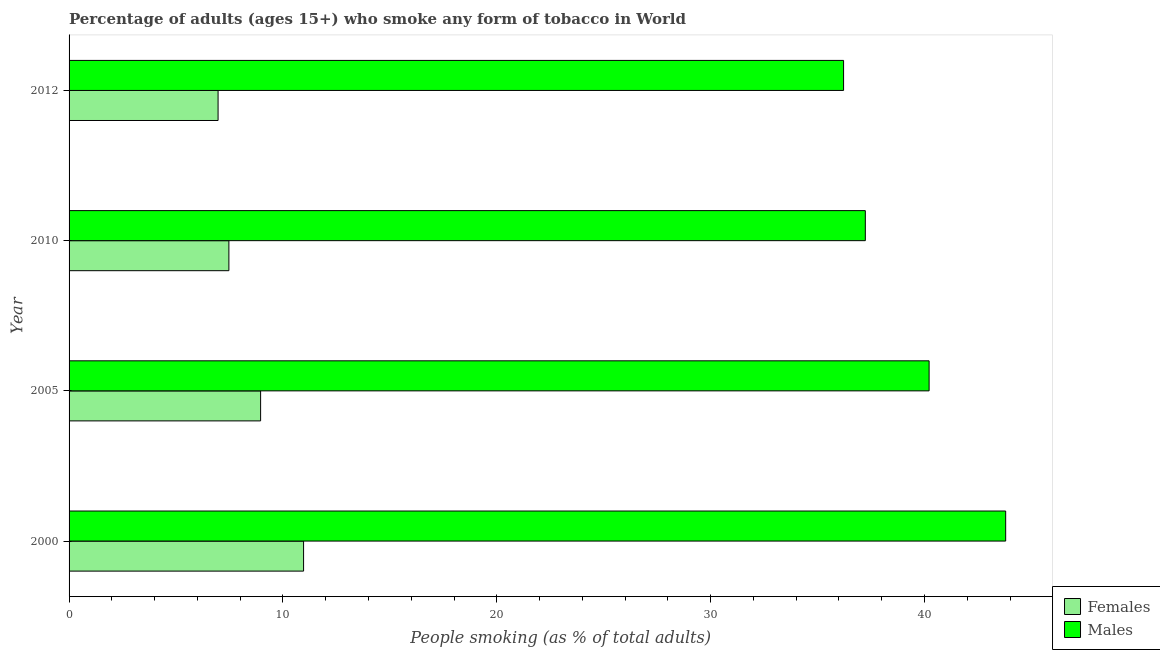How many groups of bars are there?
Ensure brevity in your answer.  4. Are the number of bars per tick equal to the number of legend labels?
Offer a terse response. Yes. In how many cases, is the number of bars for a given year not equal to the number of legend labels?
Give a very brief answer. 0. What is the percentage of males who smoke in 2012?
Your response must be concise. 36.22. Across all years, what is the maximum percentage of females who smoke?
Offer a terse response. 10.97. Across all years, what is the minimum percentage of males who smoke?
Offer a very short reply. 36.22. What is the total percentage of males who smoke in the graph?
Offer a terse response. 157.46. What is the difference between the percentage of females who smoke in 2000 and that in 2005?
Ensure brevity in your answer.  2.01. What is the difference between the percentage of males who smoke in 2000 and the percentage of females who smoke in 2005?
Keep it short and to the point. 34.84. What is the average percentage of males who smoke per year?
Your response must be concise. 39.37. In the year 2000, what is the difference between the percentage of males who smoke and percentage of females who smoke?
Keep it short and to the point. 32.83. What is the ratio of the percentage of males who smoke in 2000 to that in 2012?
Offer a very short reply. 1.21. Is the percentage of males who smoke in 2000 less than that in 2012?
Keep it short and to the point. No. What is the difference between the highest and the second highest percentage of females who smoke?
Give a very brief answer. 2.01. What is the difference between the highest and the lowest percentage of females who smoke?
Make the answer very short. 4. In how many years, is the percentage of males who smoke greater than the average percentage of males who smoke taken over all years?
Keep it short and to the point. 2. What does the 2nd bar from the top in 2010 represents?
Provide a succinct answer. Females. What does the 1st bar from the bottom in 2000 represents?
Provide a short and direct response. Females. What is the difference between two consecutive major ticks on the X-axis?
Keep it short and to the point. 10. Are the values on the major ticks of X-axis written in scientific E-notation?
Offer a very short reply. No. Does the graph contain any zero values?
Make the answer very short. No. Does the graph contain grids?
Offer a terse response. No. What is the title of the graph?
Make the answer very short. Percentage of adults (ages 15+) who smoke any form of tobacco in World. Does "Diarrhea" appear as one of the legend labels in the graph?
Keep it short and to the point. No. What is the label or title of the X-axis?
Provide a succinct answer. People smoking (as % of total adults). What is the People smoking (as % of total adults) of Females in 2000?
Ensure brevity in your answer.  10.97. What is the People smoking (as % of total adults) of Males in 2000?
Your answer should be very brief. 43.8. What is the People smoking (as % of total adults) in Females in 2005?
Offer a very short reply. 8.96. What is the People smoking (as % of total adults) of Males in 2005?
Your answer should be compact. 40.22. What is the People smoking (as % of total adults) in Females in 2010?
Keep it short and to the point. 7.47. What is the People smoking (as % of total adults) in Males in 2010?
Ensure brevity in your answer.  37.23. What is the People smoking (as % of total adults) of Females in 2012?
Your response must be concise. 6.97. What is the People smoking (as % of total adults) of Males in 2012?
Ensure brevity in your answer.  36.22. Across all years, what is the maximum People smoking (as % of total adults) of Females?
Offer a very short reply. 10.97. Across all years, what is the maximum People smoking (as % of total adults) in Males?
Ensure brevity in your answer.  43.8. Across all years, what is the minimum People smoking (as % of total adults) of Females?
Provide a succinct answer. 6.97. Across all years, what is the minimum People smoking (as % of total adults) in Males?
Your answer should be compact. 36.22. What is the total People smoking (as % of total adults) of Females in the graph?
Your answer should be very brief. 34.36. What is the total People smoking (as % of total adults) in Males in the graph?
Make the answer very short. 157.46. What is the difference between the People smoking (as % of total adults) of Females in 2000 and that in 2005?
Give a very brief answer. 2.01. What is the difference between the People smoking (as % of total adults) in Males in 2000 and that in 2005?
Your answer should be very brief. 3.58. What is the difference between the People smoking (as % of total adults) in Females in 2000 and that in 2010?
Provide a short and direct response. 3.49. What is the difference between the People smoking (as % of total adults) in Males in 2000 and that in 2010?
Your answer should be compact. 6.56. What is the difference between the People smoking (as % of total adults) in Females in 2000 and that in 2012?
Ensure brevity in your answer.  4. What is the difference between the People smoking (as % of total adults) of Males in 2000 and that in 2012?
Provide a succinct answer. 7.58. What is the difference between the People smoking (as % of total adults) of Females in 2005 and that in 2010?
Keep it short and to the point. 1.48. What is the difference between the People smoking (as % of total adults) of Males in 2005 and that in 2010?
Your answer should be very brief. 2.98. What is the difference between the People smoking (as % of total adults) of Females in 2005 and that in 2012?
Provide a short and direct response. 1.99. What is the difference between the People smoking (as % of total adults) in Males in 2005 and that in 2012?
Give a very brief answer. 4. What is the difference between the People smoking (as % of total adults) in Females in 2010 and that in 2012?
Ensure brevity in your answer.  0.51. What is the difference between the People smoking (as % of total adults) in Males in 2010 and that in 2012?
Provide a succinct answer. 1.02. What is the difference between the People smoking (as % of total adults) in Females in 2000 and the People smoking (as % of total adults) in Males in 2005?
Your answer should be very brief. -29.25. What is the difference between the People smoking (as % of total adults) in Females in 2000 and the People smoking (as % of total adults) in Males in 2010?
Offer a very short reply. -26.27. What is the difference between the People smoking (as % of total adults) of Females in 2000 and the People smoking (as % of total adults) of Males in 2012?
Offer a terse response. -25.25. What is the difference between the People smoking (as % of total adults) in Females in 2005 and the People smoking (as % of total adults) in Males in 2010?
Offer a very short reply. -28.28. What is the difference between the People smoking (as % of total adults) of Females in 2005 and the People smoking (as % of total adults) of Males in 2012?
Offer a terse response. -27.26. What is the difference between the People smoking (as % of total adults) of Females in 2010 and the People smoking (as % of total adults) of Males in 2012?
Ensure brevity in your answer.  -28.74. What is the average People smoking (as % of total adults) of Females per year?
Make the answer very short. 8.59. What is the average People smoking (as % of total adults) in Males per year?
Provide a succinct answer. 39.37. In the year 2000, what is the difference between the People smoking (as % of total adults) of Females and People smoking (as % of total adults) of Males?
Ensure brevity in your answer.  -32.83. In the year 2005, what is the difference between the People smoking (as % of total adults) in Females and People smoking (as % of total adults) in Males?
Your answer should be compact. -31.26. In the year 2010, what is the difference between the People smoking (as % of total adults) of Females and People smoking (as % of total adults) of Males?
Ensure brevity in your answer.  -29.76. In the year 2012, what is the difference between the People smoking (as % of total adults) of Females and People smoking (as % of total adults) of Males?
Provide a short and direct response. -29.25. What is the ratio of the People smoking (as % of total adults) of Females in 2000 to that in 2005?
Provide a succinct answer. 1.22. What is the ratio of the People smoking (as % of total adults) of Males in 2000 to that in 2005?
Make the answer very short. 1.09. What is the ratio of the People smoking (as % of total adults) of Females in 2000 to that in 2010?
Make the answer very short. 1.47. What is the ratio of the People smoking (as % of total adults) in Males in 2000 to that in 2010?
Ensure brevity in your answer.  1.18. What is the ratio of the People smoking (as % of total adults) of Females in 2000 to that in 2012?
Make the answer very short. 1.57. What is the ratio of the People smoking (as % of total adults) of Males in 2000 to that in 2012?
Offer a very short reply. 1.21. What is the ratio of the People smoking (as % of total adults) of Females in 2005 to that in 2010?
Give a very brief answer. 1.2. What is the ratio of the People smoking (as % of total adults) of Males in 2005 to that in 2010?
Ensure brevity in your answer.  1.08. What is the ratio of the People smoking (as % of total adults) in Females in 2005 to that in 2012?
Your answer should be compact. 1.29. What is the ratio of the People smoking (as % of total adults) of Males in 2005 to that in 2012?
Offer a very short reply. 1.11. What is the ratio of the People smoking (as % of total adults) in Females in 2010 to that in 2012?
Your response must be concise. 1.07. What is the ratio of the People smoking (as % of total adults) in Males in 2010 to that in 2012?
Your response must be concise. 1.03. What is the difference between the highest and the second highest People smoking (as % of total adults) of Females?
Keep it short and to the point. 2.01. What is the difference between the highest and the second highest People smoking (as % of total adults) of Males?
Your answer should be compact. 3.58. What is the difference between the highest and the lowest People smoking (as % of total adults) of Females?
Make the answer very short. 4. What is the difference between the highest and the lowest People smoking (as % of total adults) in Males?
Provide a short and direct response. 7.58. 